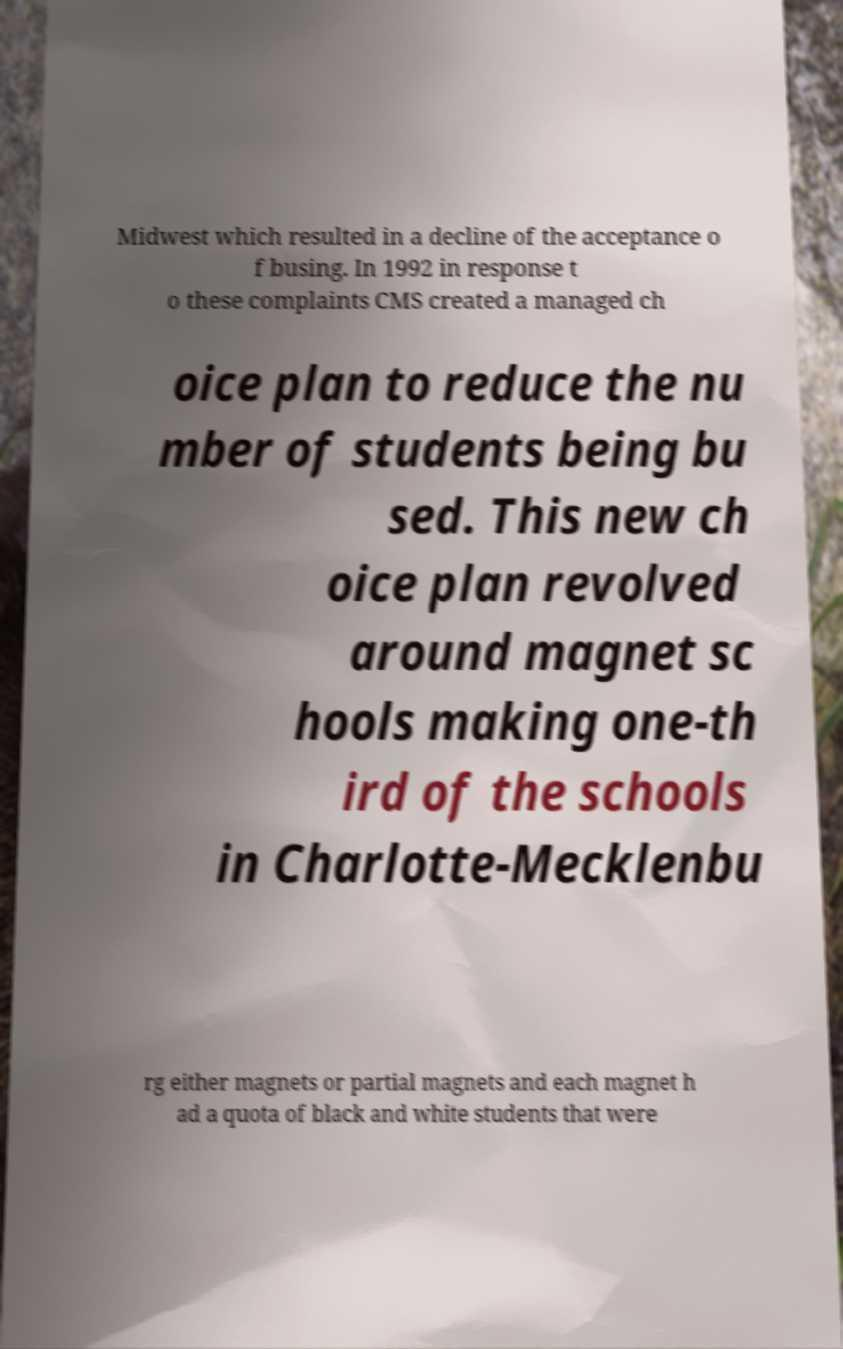There's text embedded in this image that I need extracted. Can you transcribe it verbatim? Midwest which resulted in a decline of the acceptance o f busing. In 1992 in response t o these complaints CMS created a managed ch oice plan to reduce the nu mber of students being bu sed. This new ch oice plan revolved around magnet sc hools making one-th ird of the schools in Charlotte-Mecklenbu rg either magnets or partial magnets and each magnet h ad a quota of black and white students that were 